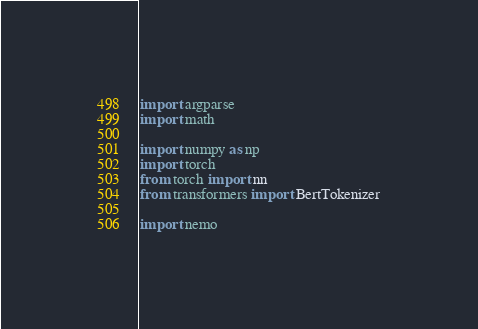<code> <loc_0><loc_0><loc_500><loc_500><_Python_>import argparse
import math

import numpy as np
import torch
from torch import nn
from transformers import BertTokenizer

import nemo</code> 